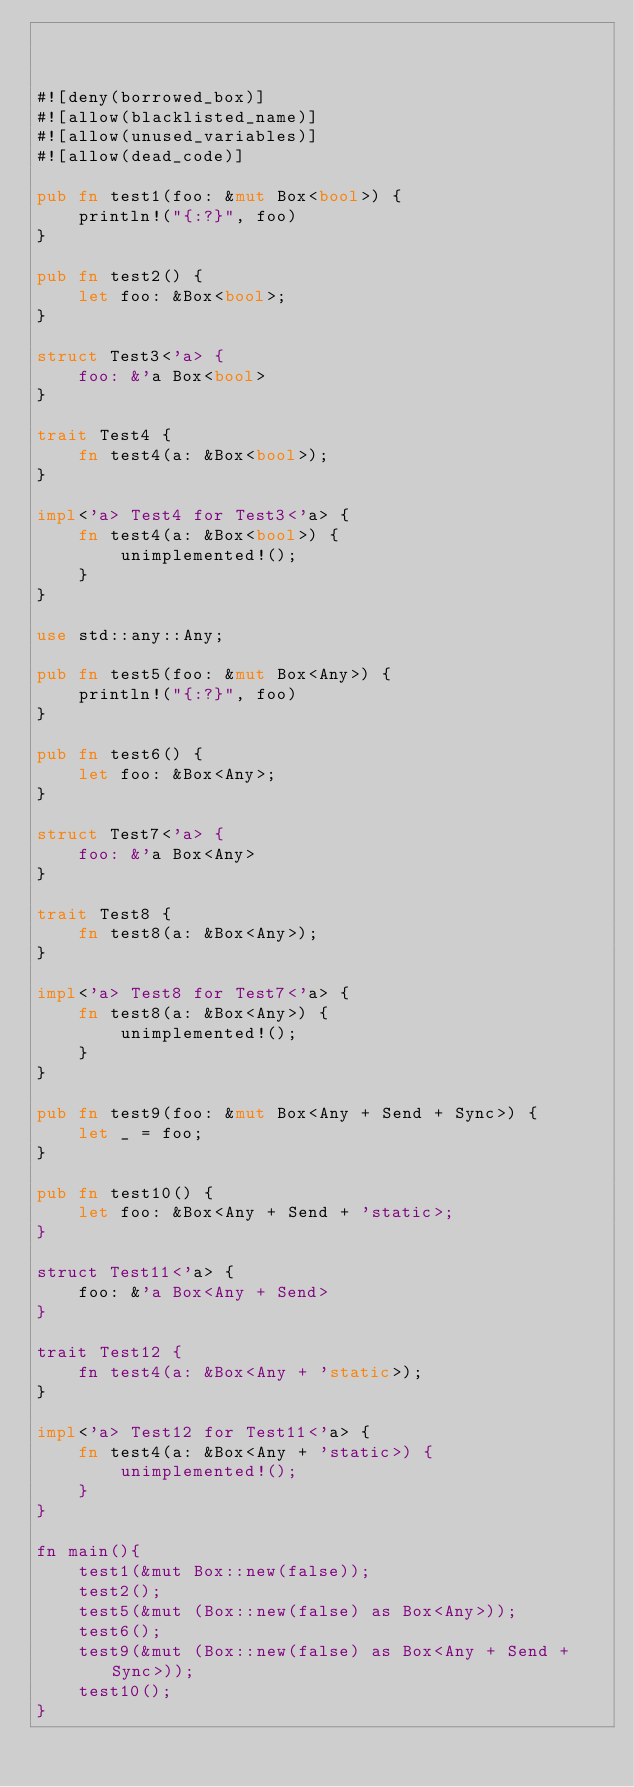<code> <loc_0><loc_0><loc_500><loc_500><_Rust_>


#![deny(borrowed_box)]
#![allow(blacklisted_name)]
#![allow(unused_variables)]
#![allow(dead_code)]

pub fn test1(foo: &mut Box<bool>) {
    println!("{:?}", foo)
}

pub fn test2() {
    let foo: &Box<bool>;
}

struct Test3<'a> {
    foo: &'a Box<bool>
}

trait Test4 {
    fn test4(a: &Box<bool>);
}

impl<'a> Test4 for Test3<'a> {
    fn test4(a: &Box<bool>) {
        unimplemented!();
    }
}

use std::any::Any;

pub fn test5(foo: &mut Box<Any>) {
    println!("{:?}", foo)
}

pub fn test6() {
    let foo: &Box<Any>;
}

struct Test7<'a> {
    foo: &'a Box<Any>
}

trait Test8 {
    fn test8(a: &Box<Any>);
}

impl<'a> Test8 for Test7<'a> {
    fn test8(a: &Box<Any>) {
        unimplemented!();
    }
}

pub fn test9(foo: &mut Box<Any + Send + Sync>) {
    let _ = foo;
}

pub fn test10() {
    let foo: &Box<Any + Send + 'static>;
}

struct Test11<'a> {
    foo: &'a Box<Any + Send>
}

trait Test12 {
    fn test4(a: &Box<Any + 'static>);
}

impl<'a> Test12 for Test11<'a> {
    fn test4(a: &Box<Any + 'static>) {
        unimplemented!();
    }
}

fn main(){
    test1(&mut Box::new(false));
    test2();
    test5(&mut (Box::new(false) as Box<Any>));
    test6();
    test9(&mut (Box::new(false) as Box<Any + Send + Sync>));
    test10();
}
</code> 